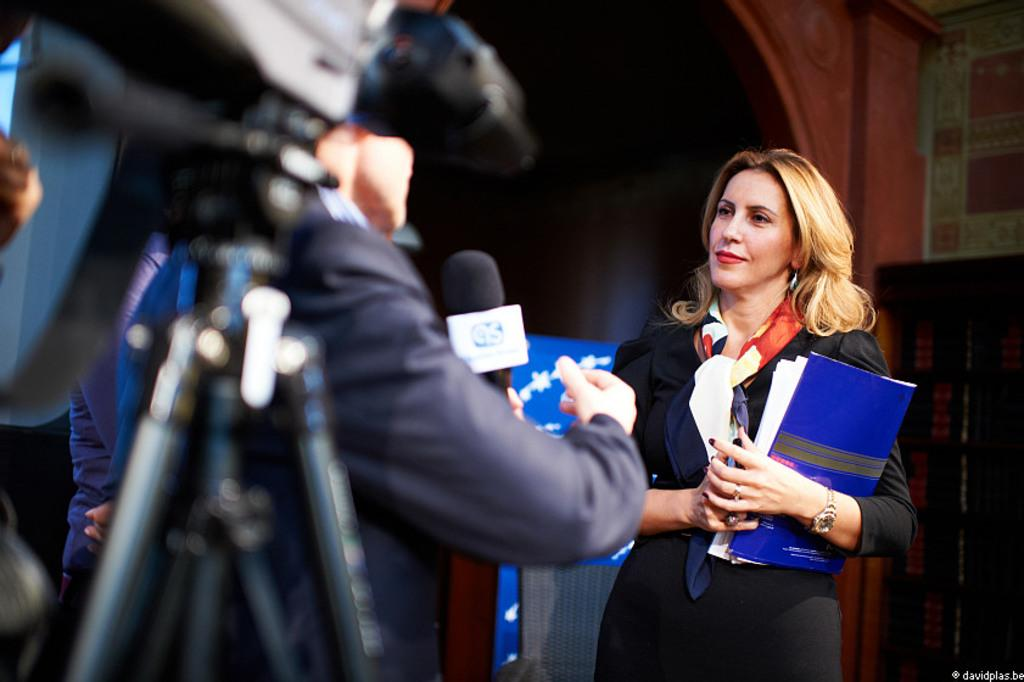Who or what is present in the image? There are people in the image. What equipment can be seen on the left side of the image? There is a camera and a microphone on the left side of the image. What is visible in the background of the image? There is a wall in the background of the image. What type of winter clothing is the mom wearing in the image? There is no mom or winter clothing present in the image. How close to the edge of the image are the people standing? The image does not provide information about the position of the people relative to the edge of the image. 